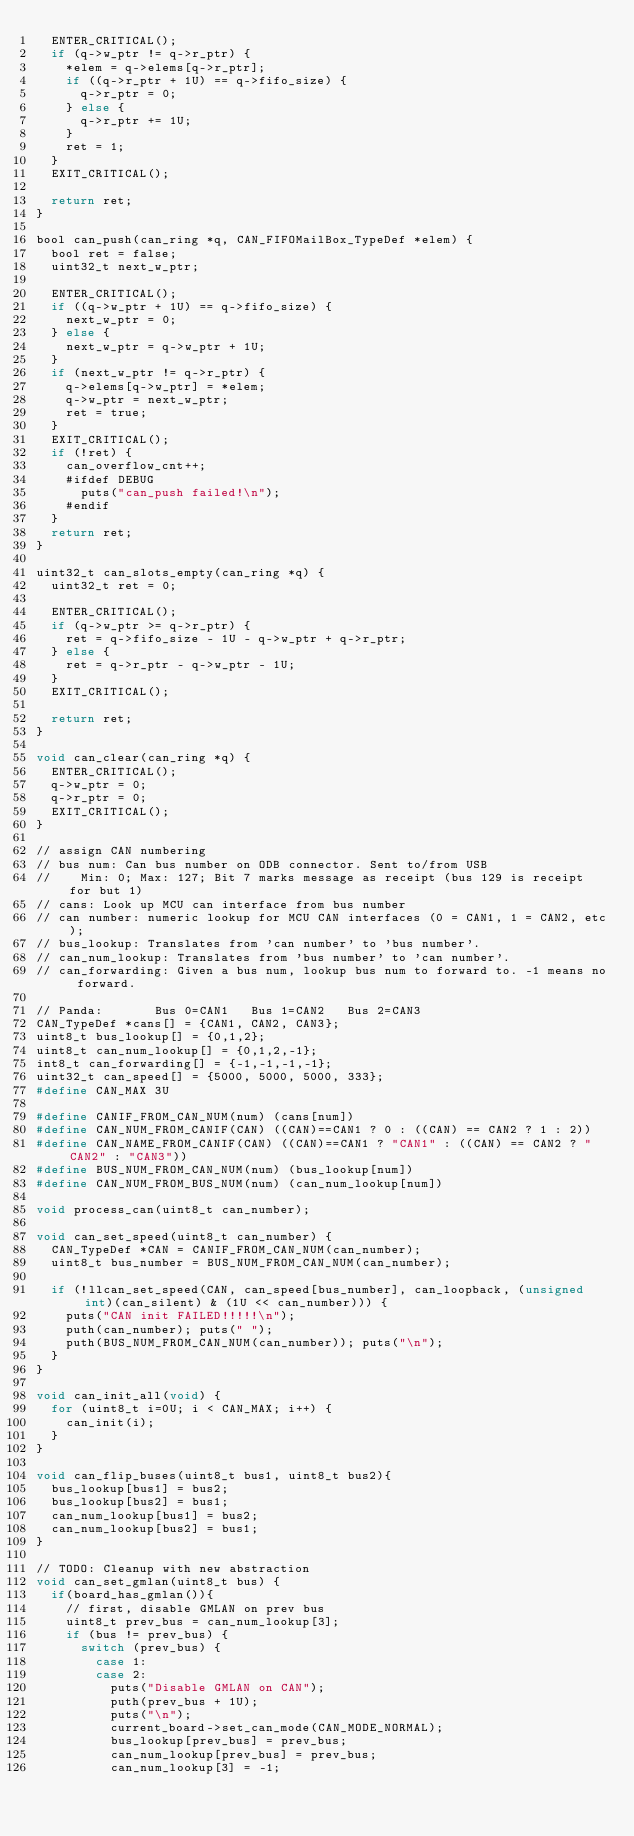<code> <loc_0><loc_0><loc_500><loc_500><_C_>  ENTER_CRITICAL();
  if (q->w_ptr != q->r_ptr) {
    *elem = q->elems[q->r_ptr];
    if ((q->r_ptr + 1U) == q->fifo_size) {
      q->r_ptr = 0;
    } else {
      q->r_ptr += 1U;
    }
    ret = 1;
  }
  EXIT_CRITICAL();

  return ret;
}

bool can_push(can_ring *q, CAN_FIFOMailBox_TypeDef *elem) {
  bool ret = false;
  uint32_t next_w_ptr;

  ENTER_CRITICAL();
  if ((q->w_ptr + 1U) == q->fifo_size) {
    next_w_ptr = 0;
  } else {
    next_w_ptr = q->w_ptr + 1U;
  }
  if (next_w_ptr != q->r_ptr) {
    q->elems[q->w_ptr] = *elem;
    q->w_ptr = next_w_ptr;
    ret = true;
  }
  EXIT_CRITICAL();
  if (!ret) {
    can_overflow_cnt++;
    #ifdef DEBUG
      puts("can_push failed!\n");
    #endif
  }
  return ret;
}

uint32_t can_slots_empty(can_ring *q) {
  uint32_t ret = 0;

  ENTER_CRITICAL();
  if (q->w_ptr >= q->r_ptr) {
    ret = q->fifo_size - 1U - q->w_ptr + q->r_ptr;
  } else {
    ret = q->r_ptr - q->w_ptr - 1U;
  }
  EXIT_CRITICAL();

  return ret;
}

void can_clear(can_ring *q) {
  ENTER_CRITICAL();
  q->w_ptr = 0;
  q->r_ptr = 0;
  EXIT_CRITICAL();
}

// assign CAN numbering
// bus num: Can bus number on ODB connector. Sent to/from USB
//    Min: 0; Max: 127; Bit 7 marks message as receipt (bus 129 is receipt for but 1)
// cans: Look up MCU can interface from bus number
// can number: numeric lookup for MCU CAN interfaces (0 = CAN1, 1 = CAN2, etc);
// bus_lookup: Translates from 'can number' to 'bus number'.
// can_num_lookup: Translates from 'bus number' to 'can number'.
// can_forwarding: Given a bus num, lookup bus num to forward to. -1 means no forward.

// Panda:       Bus 0=CAN1   Bus 1=CAN2   Bus 2=CAN3
CAN_TypeDef *cans[] = {CAN1, CAN2, CAN3};
uint8_t bus_lookup[] = {0,1,2};
uint8_t can_num_lookup[] = {0,1,2,-1};
int8_t can_forwarding[] = {-1,-1,-1,-1};
uint32_t can_speed[] = {5000, 5000, 5000, 333};
#define CAN_MAX 3U

#define CANIF_FROM_CAN_NUM(num) (cans[num])
#define CAN_NUM_FROM_CANIF(CAN) ((CAN)==CAN1 ? 0 : ((CAN) == CAN2 ? 1 : 2))
#define CAN_NAME_FROM_CANIF(CAN) ((CAN)==CAN1 ? "CAN1" : ((CAN) == CAN2 ? "CAN2" : "CAN3"))
#define BUS_NUM_FROM_CAN_NUM(num) (bus_lookup[num])
#define CAN_NUM_FROM_BUS_NUM(num) (can_num_lookup[num])

void process_can(uint8_t can_number);

void can_set_speed(uint8_t can_number) {
  CAN_TypeDef *CAN = CANIF_FROM_CAN_NUM(can_number);
  uint8_t bus_number = BUS_NUM_FROM_CAN_NUM(can_number);

  if (!llcan_set_speed(CAN, can_speed[bus_number], can_loopback, (unsigned int)(can_silent) & (1U << can_number))) {
    puts("CAN init FAILED!!!!!\n");
    puth(can_number); puts(" ");
    puth(BUS_NUM_FROM_CAN_NUM(can_number)); puts("\n");
  }
}

void can_init_all(void) {
  for (uint8_t i=0U; i < CAN_MAX; i++) {
    can_init(i);
  }
}

void can_flip_buses(uint8_t bus1, uint8_t bus2){
  bus_lookup[bus1] = bus2;
  bus_lookup[bus2] = bus1;
  can_num_lookup[bus1] = bus2;
  can_num_lookup[bus2] = bus1;
}

// TODO: Cleanup with new abstraction
void can_set_gmlan(uint8_t bus) {
  if(board_has_gmlan()){
    // first, disable GMLAN on prev bus
    uint8_t prev_bus = can_num_lookup[3];
    if (bus != prev_bus) {
      switch (prev_bus) {
        case 1:
        case 2:
          puts("Disable GMLAN on CAN");
          puth(prev_bus + 1U);
          puts("\n");
          current_board->set_can_mode(CAN_MODE_NORMAL);
          bus_lookup[prev_bus] = prev_bus;
          can_num_lookup[prev_bus] = prev_bus;
          can_num_lookup[3] = -1;</code> 